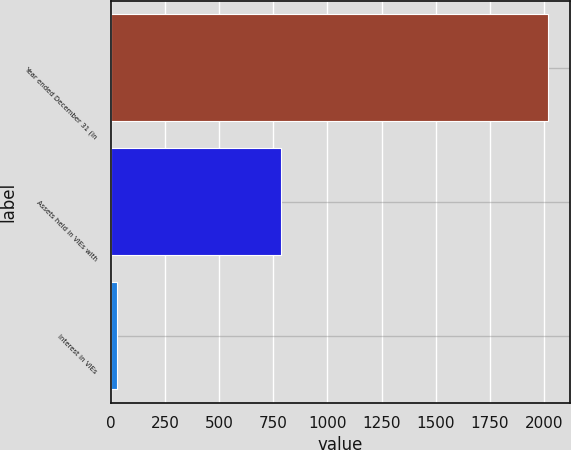Convert chart. <chart><loc_0><loc_0><loc_500><loc_500><bar_chart><fcel>Year ended December 31 (in<fcel>Assets held in VIEs with<fcel>Interest in VIEs<nl><fcel>2017<fcel>783<fcel>29<nl></chart> 